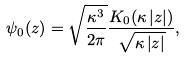<formula> <loc_0><loc_0><loc_500><loc_500>\psi _ { 0 } ( z ) = \sqrt { \frac { \kappa ^ { 3 } } { 2 \pi } } \frac { K _ { 0 } ( \kappa \left | z \right | ) } { \sqrt { \kappa \left | z \right | } } ,</formula> 